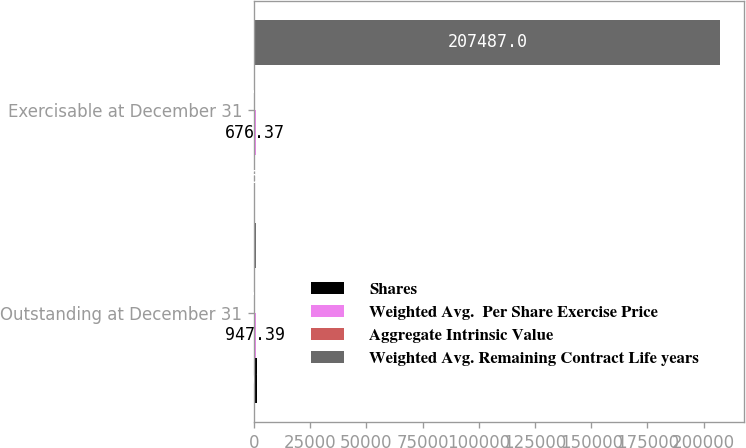<chart> <loc_0><loc_0><loc_500><loc_500><stacked_bar_chart><ecel><fcel>Outstanding at December 31<fcel>Exercisable at December 31<nl><fcel>Shares<fcel>1201<fcel>346<nl><fcel>Weighted Avg.  Per Share Exercise Price<fcel>947.39<fcel>676.37<nl><fcel>Aggregate Intrinsic Value<fcel>7.9<fcel>5.1<nl><fcel>Weighted Avg. Remaining Contract Life years<fcel>676.37<fcel>207487<nl></chart> 